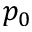Convert formula to latex. <formula><loc_0><loc_0><loc_500><loc_500>p _ { 0 }</formula> 